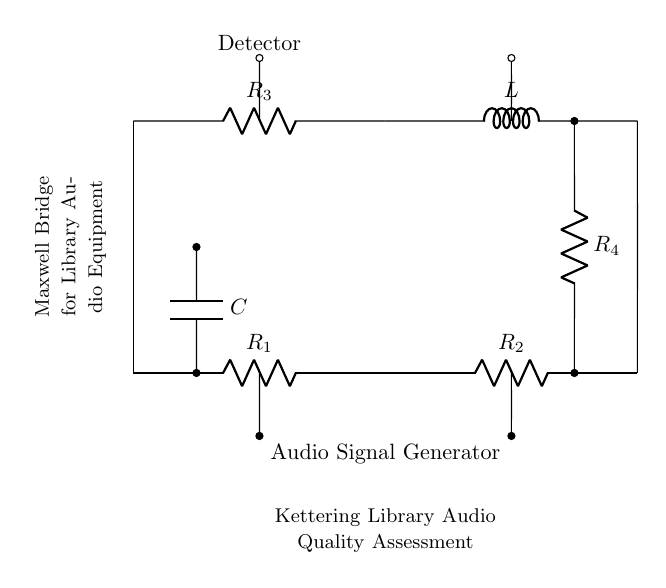What type of components are present in this circuit? The circuit contains resistors, an inductor, and a capacitor, all of which are fundamental components of a Maxwell Bridge.
Answer: resistors, inductor, capacitor What is the configuration type of this bridge circuit? This is a Maxwell Bridge circuit specifically designed for measuring impedance, consisting of various resistive and reactive components organized in a bridge layout.
Answer: Maxwell Bridge What does the audio signal generator do in this circuit? The audio signal generator provides an alternating current signal that is necessary for testing the audio equipment's response and the quality of the sound system.
Answer: provide audio signal How many resistors are used in this circuit? There are four resistors in this Maxwell Bridge circuit: R1, R2, R3, and R4.
Answer: four Why is a detector included in the circuit? The detector's role is to measure the output signal of the bridge, allowing for the assessment of the equipment's performance by comparing the input and output signals.
Answer: to measure output signal What is the purpose of the capacitor in the circuit? The capacitor is used to store electrical energy temporarily and helps in balancing the bridge by influencing the impedance of the circuit.
Answer: to balance impedance What could potentially happen if one component in the bridge gets removed? Removing a component would disrupt the balance of the Maxwell Bridge, preventing accurate measurement of the impedance or quality of the audio signal.
Answer: disrupt circuit balance 